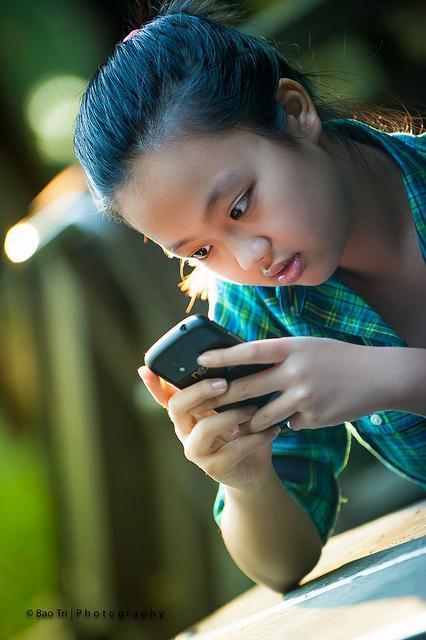How many people are there?
Give a very brief answer. 1. 